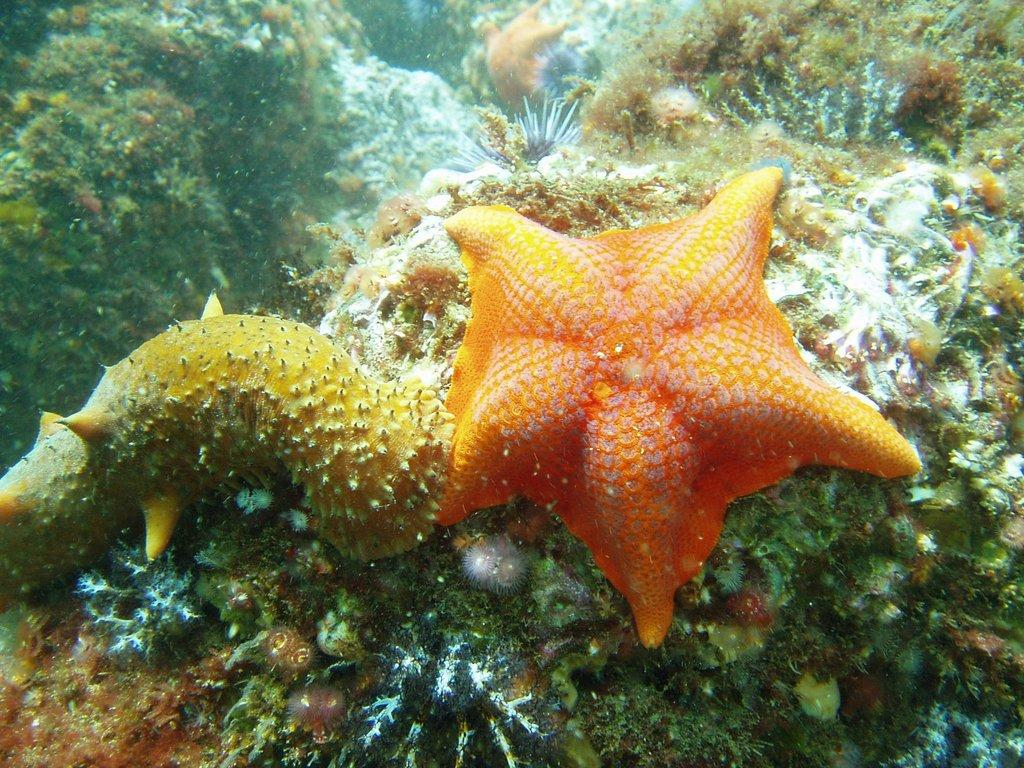What type of animal is in the image? There is a starfish in the image. Where is the starfish located? The starfish is in the water. What type of quilt is being used to cover the coast in the image? There is no quilt or coast present in the image; it features a starfish in the water. 